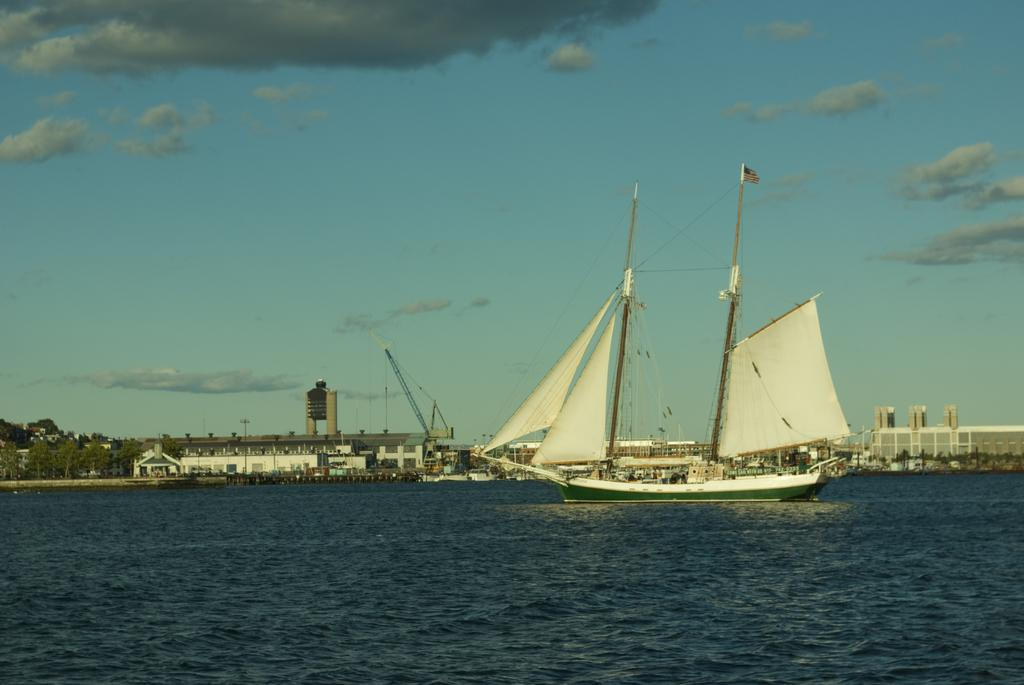What can be seen in the sky in the background of the image? There are clouds in the sky in the background of the image. What is the main subject of the image? There is a boat in the image. What are the sails made of in the image? There are sail cloths in the image. What type of equipment is present in the image? There is a crane in the image. What are the poles used for in the image? The poles are likely used for supporting the sails or other structures in the image. What type of environment is depicted in the image? There is water visible in the image, as well as trees and buildings, suggesting a coastal or waterfront setting. What type of control is used to operate the quiver in the image? There is no quiver present in the image; it is a boat with sail cloths and a crane. 